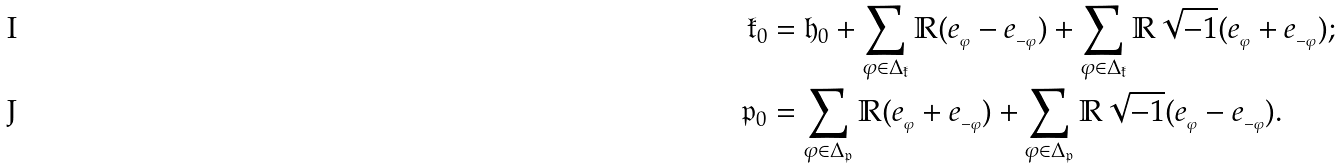Convert formula to latex. <formula><loc_0><loc_0><loc_500><loc_500>\mathfrak { k } _ { 0 } & = \mathfrak { h } _ { 0 } + \sum _ { \varphi \in \Delta _ { \mathfrak { k } } } \mathbb { R } ( e _ { _ { \varphi } } - e _ { _ { - \varphi } } ) + \sum _ { \varphi \in \Delta _ { \mathfrak { k } } } \mathbb { R } \sqrt { - 1 } ( e _ { _ { \varphi } } + e _ { _ { - \varphi } } ) ; \\ \mathfrak { p } _ { 0 } & = \sum _ { \varphi \in \Delta _ { \mathfrak { p } } } \mathbb { R } ( e _ { _ { \varphi } } + e _ { _ { - \varphi } } ) + \sum _ { \varphi \in \Delta _ { \mathfrak { p } } } \mathbb { R } \sqrt { - 1 } ( e _ { _ { \varphi } } - e _ { _ { - \varphi } } ) .</formula> 